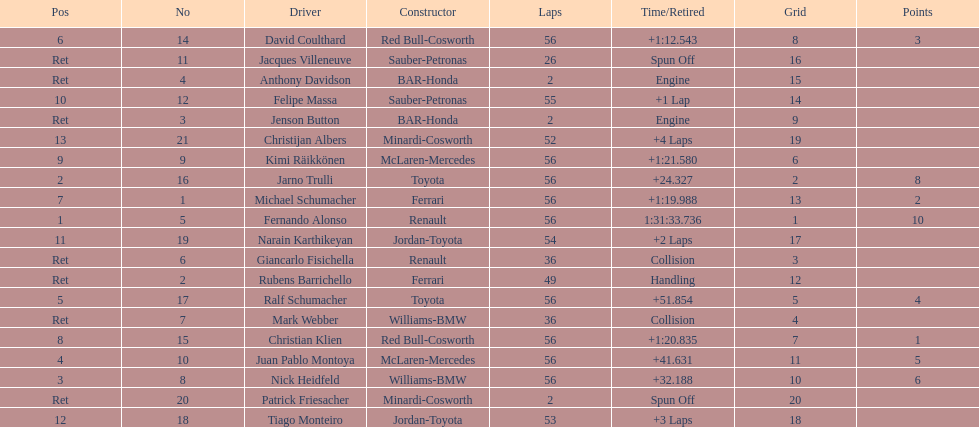Who finished before nick heidfeld? Jarno Trulli. 